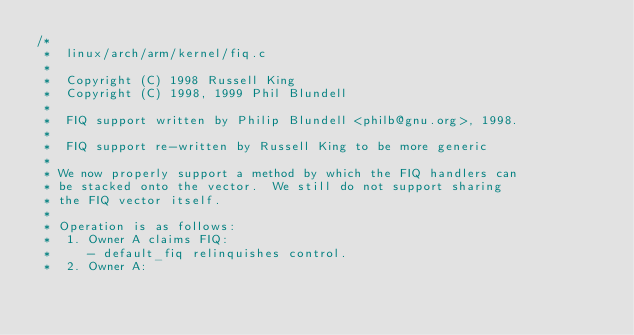<code> <loc_0><loc_0><loc_500><loc_500><_C_>/*
 *  linux/arch/arm/kernel/fiq.c
 *
 *  Copyright (C) 1998 Russell King
 *  Copyright (C) 1998, 1999 Phil Blundell
 *
 *  FIQ support written by Philip Blundell <philb@gnu.org>, 1998.
 *
 *  FIQ support re-written by Russell King to be more generic
 *
 * We now properly support a method by which the FIQ handlers can
 * be stacked onto the vector.  We still do not support sharing
 * the FIQ vector itself.
 *
 * Operation is as follows:
 *  1. Owner A claims FIQ:
 *     - default_fiq relinquishes control.
 *  2. Owner A:</code> 